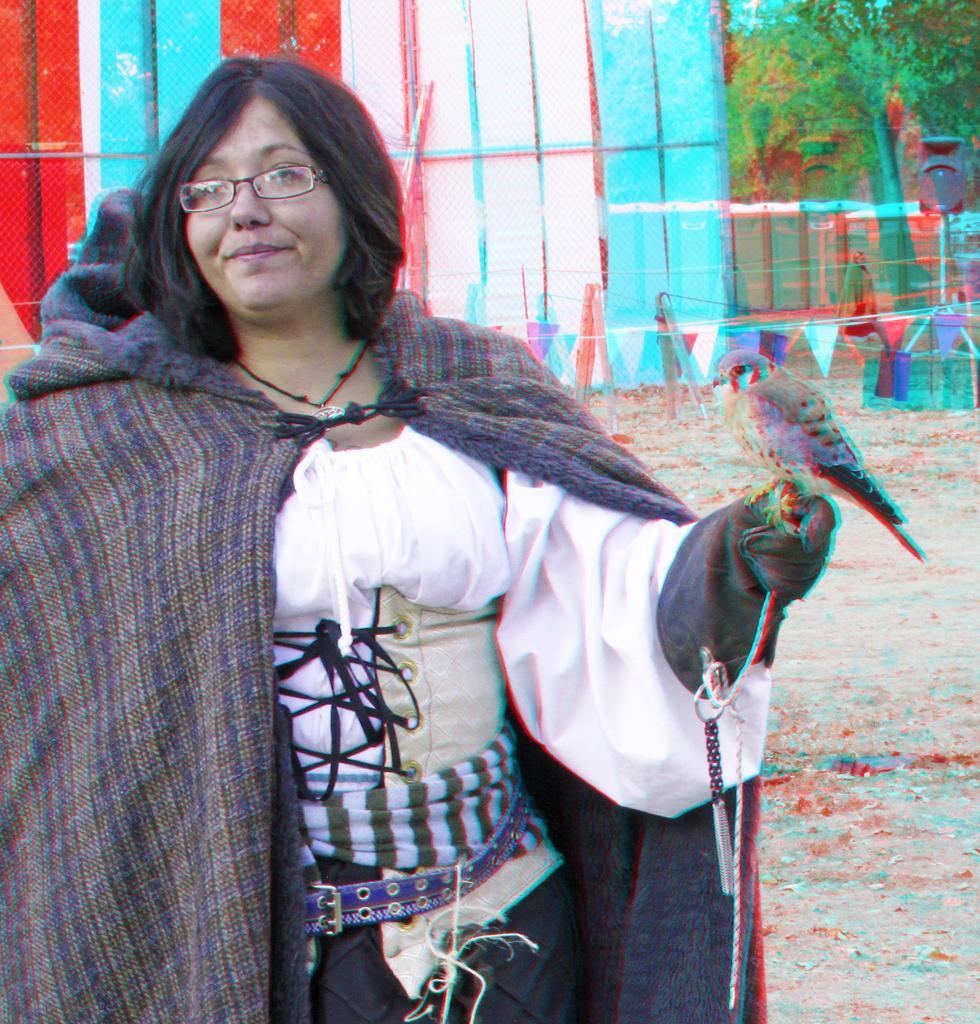In one or two sentences, can you explain what this image depicts? In this image, we can see a person wearing clothes and spectacles. There is a bird on the right side of the image. There is a in the top right of the image. 